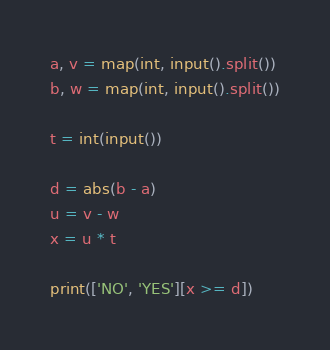Convert code to text. <code><loc_0><loc_0><loc_500><loc_500><_Python_>a, v = map(int, input().split())
b, w = map(int, input().split())

t = int(input())

d = abs(b - a)
u = v - w
x = u * t

print(['NO', 'YES'][x >= d])</code> 